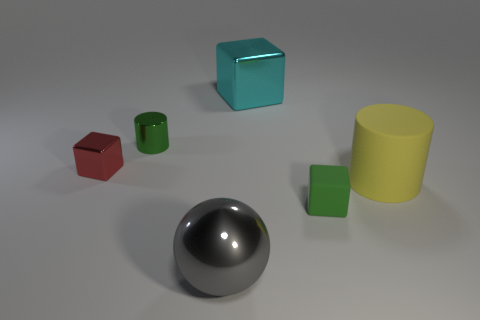Is the shape of the large object right of the small green matte thing the same as the large metal thing that is in front of the tiny green shiny cylinder?
Provide a short and direct response. No. There is a big cyan object that is the same shape as the tiny red thing; what is it made of?
Ensure brevity in your answer.  Metal. How many spheres are gray things or small green metallic objects?
Keep it short and to the point. 1. What number of tiny green things have the same material as the red object?
Give a very brief answer. 1. Is the cube on the left side of the large ball made of the same material as the tiny green object that is in front of the green metallic cylinder?
Provide a succinct answer. No. There is a cylinder that is to the right of the block that is in front of the big yellow object; what number of cylinders are behind it?
Your response must be concise. 1. There is a cylinder that is on the right side of the green cube; is it the same color as the small cube behind the yellow rubber object?
Your answer should be compact. No. Is there any other thing that is the same color as the big cylinder?
Give a very brief answer. No. There is a cylinder to the right of the metal block that is behind the green cylinder; what is its color?
Give a very brief answer. Yellow. Is there a big red rubber cylinder?
Offer a terse response. No. 